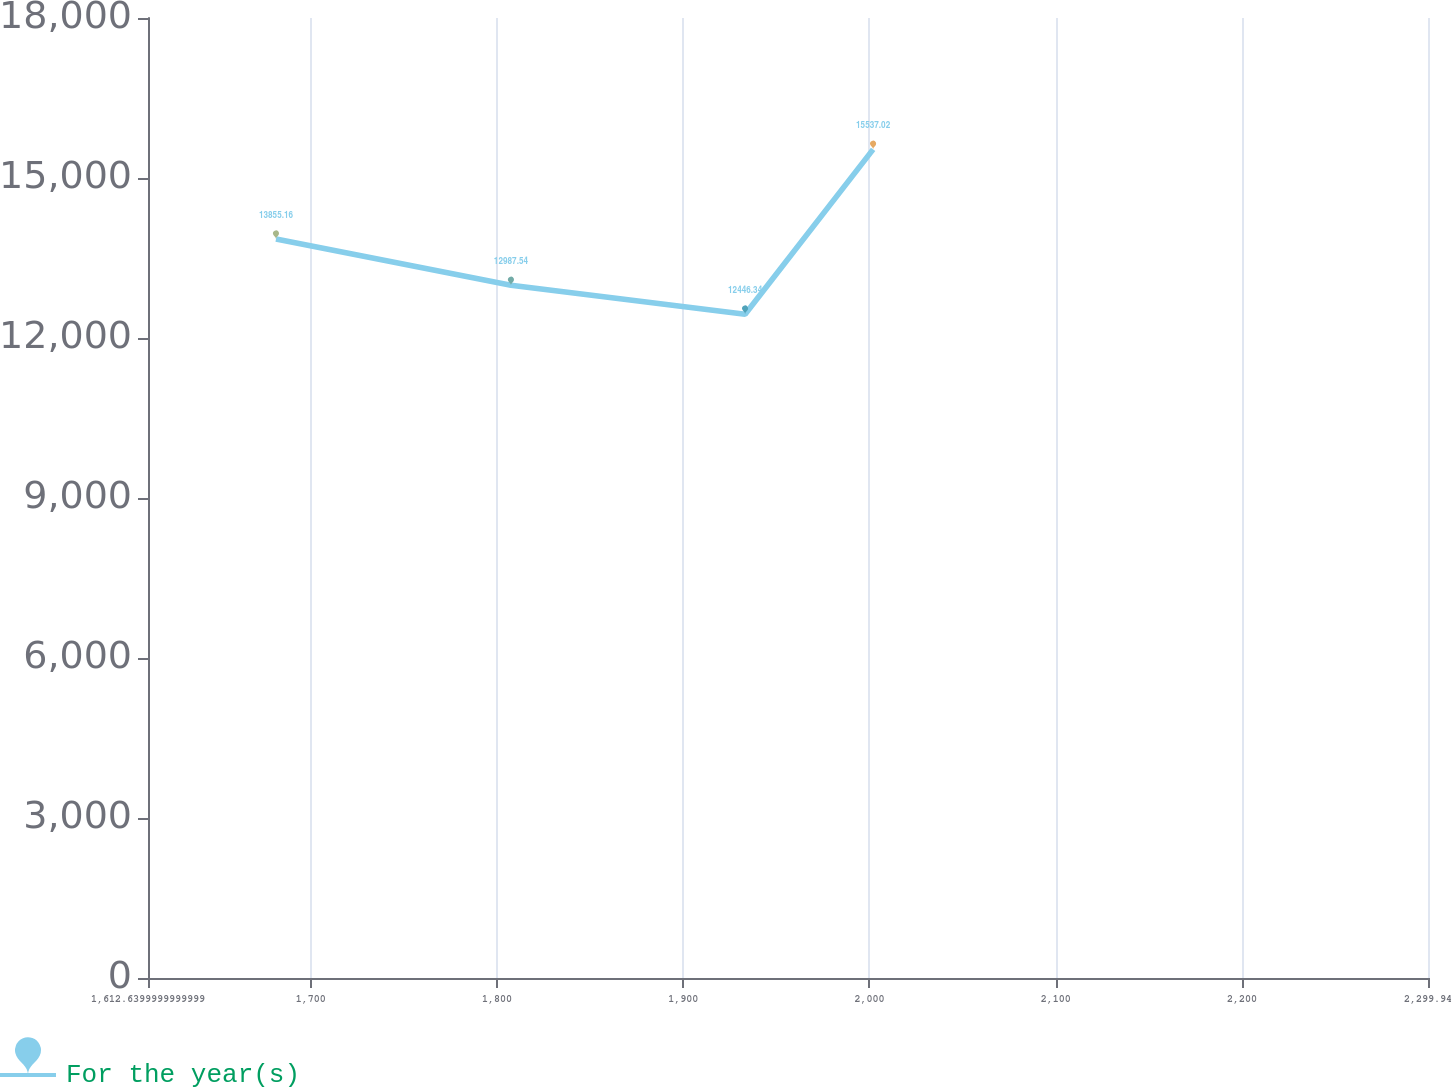<chart> <loc_0><loc_0><loc_500><loc_500><line_chart><ecel><fcel>For the year(s)<nl><fcel>1681.37<fcel>13855.2<nl><fcel>1807.54<fcel>12987.5<nl><fcel>1933.26<fcel>12446.3<nl><fcel>2001.99<fcel>15537<nl><fcel>2368.67<fcel>17403.5<nl></chart> 